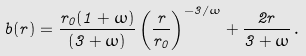<formula> <loc_0><loc_0><loc_500><loc_500>b ( r ) = \frac { r _ { 0 } ( 1 + \omega ) } { ( 3 + \omega ) } \left ( \frac { r } { r _ { 0 } } \right ) ^ { - 3 / \omega } + \frac { 2 r } { 3 + \omega } \, .</formula> 